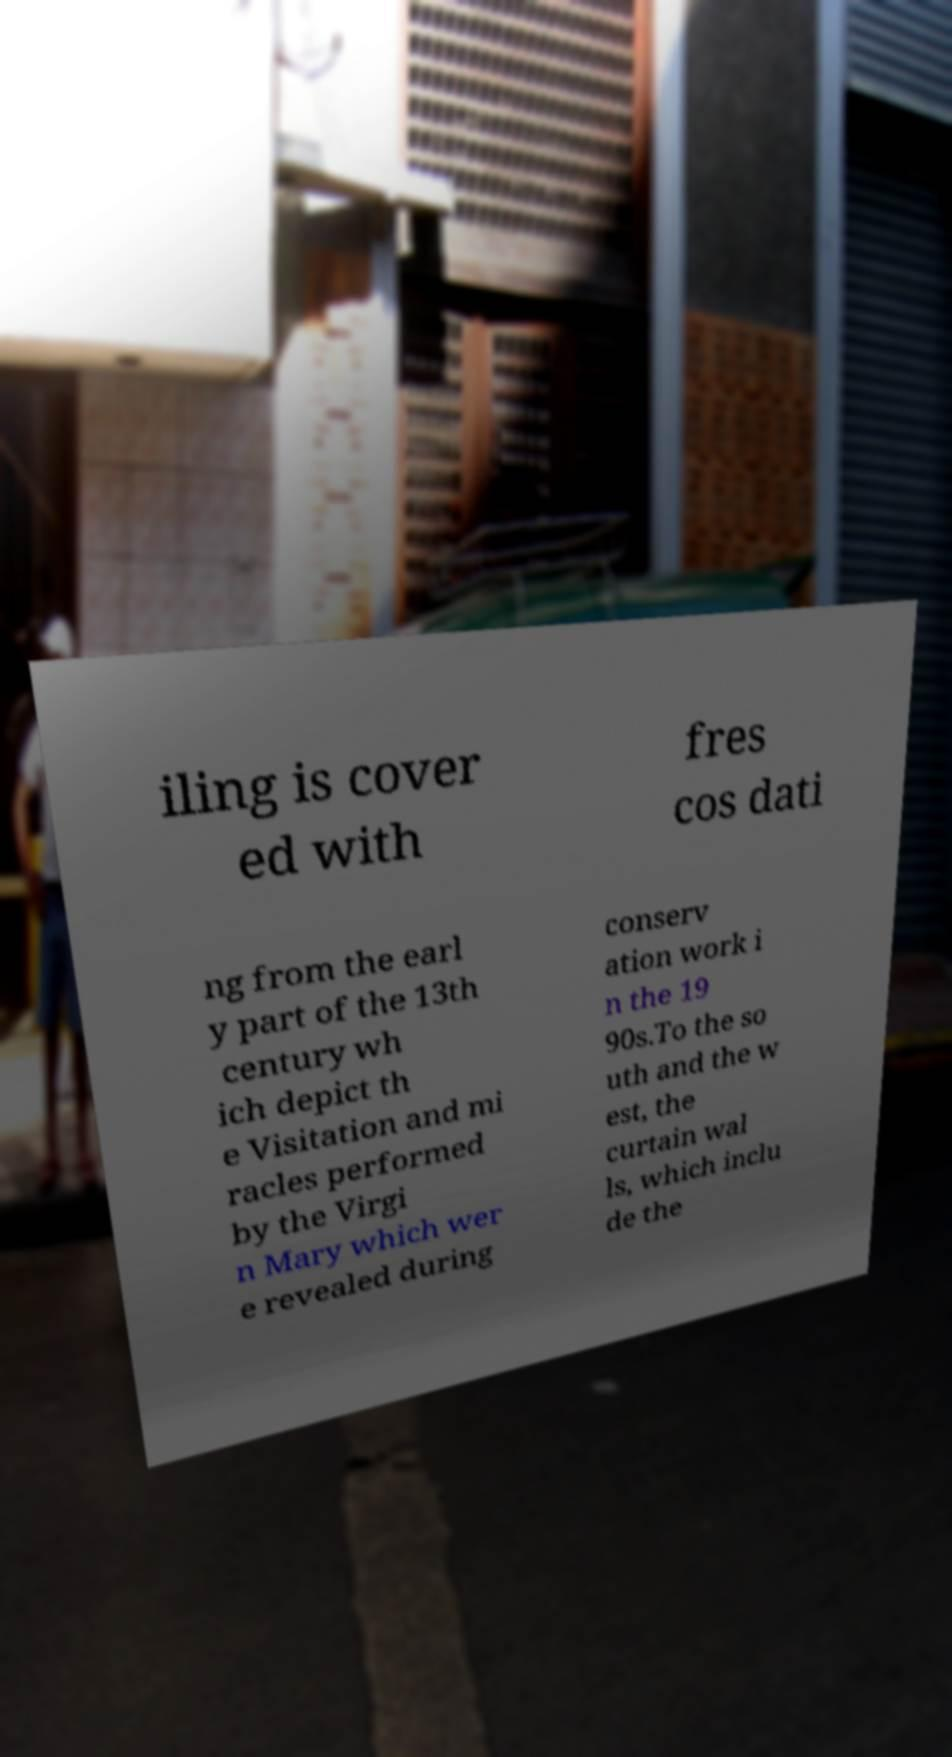For documentation purposes, I need the text within this image transcribed. Could you provide that? iling is cover ed with fres cos dati ng from the earl y part of the 13th century wh ich depict th e Visitation and mi racles performed by the Virgi n Mary which wer e revealed during conserv ation work i n the 19 90s.To the so uth and the w est, the curtain wal ls, which inclu de the 